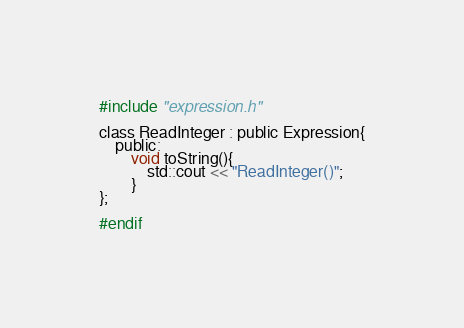Convert code to text. <code><loc_0><loc_0><loc_500><loc_500><_C_>
#include "expression.h"

class ReadInteger : public Expression{
	public:
		void toString(){
			std::cout << "ReadInteger()";
		}
};

#endif</code> 